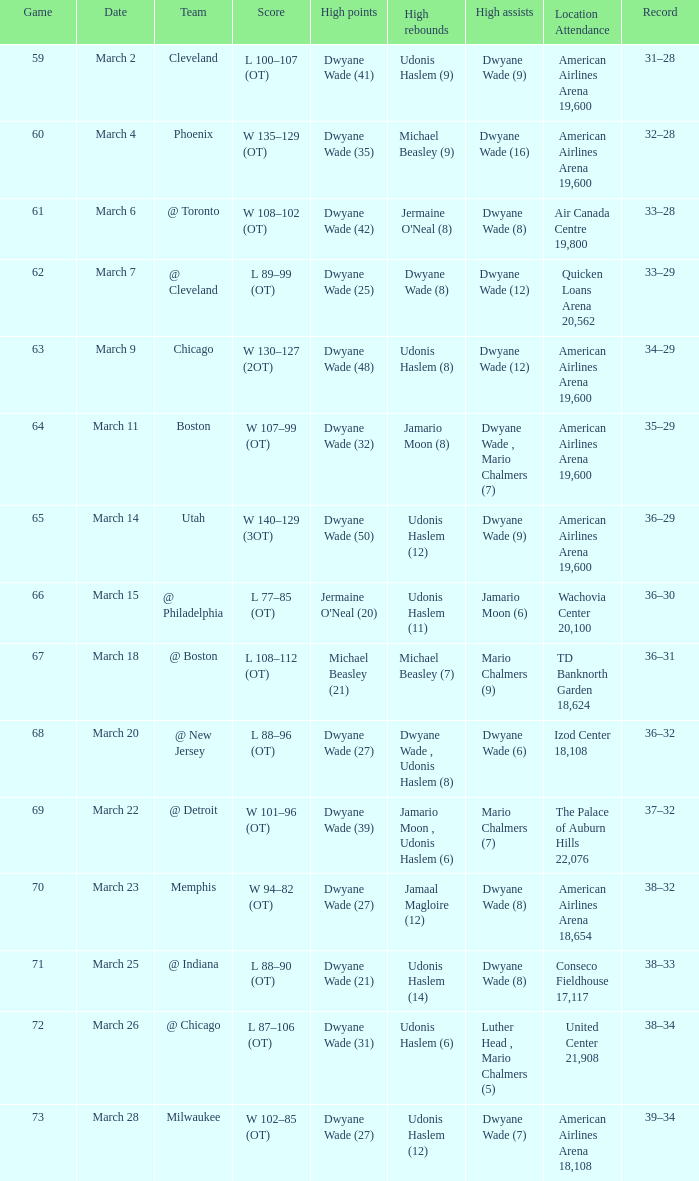Who had the high point total against cleveland? Dwyane Wade (41). 